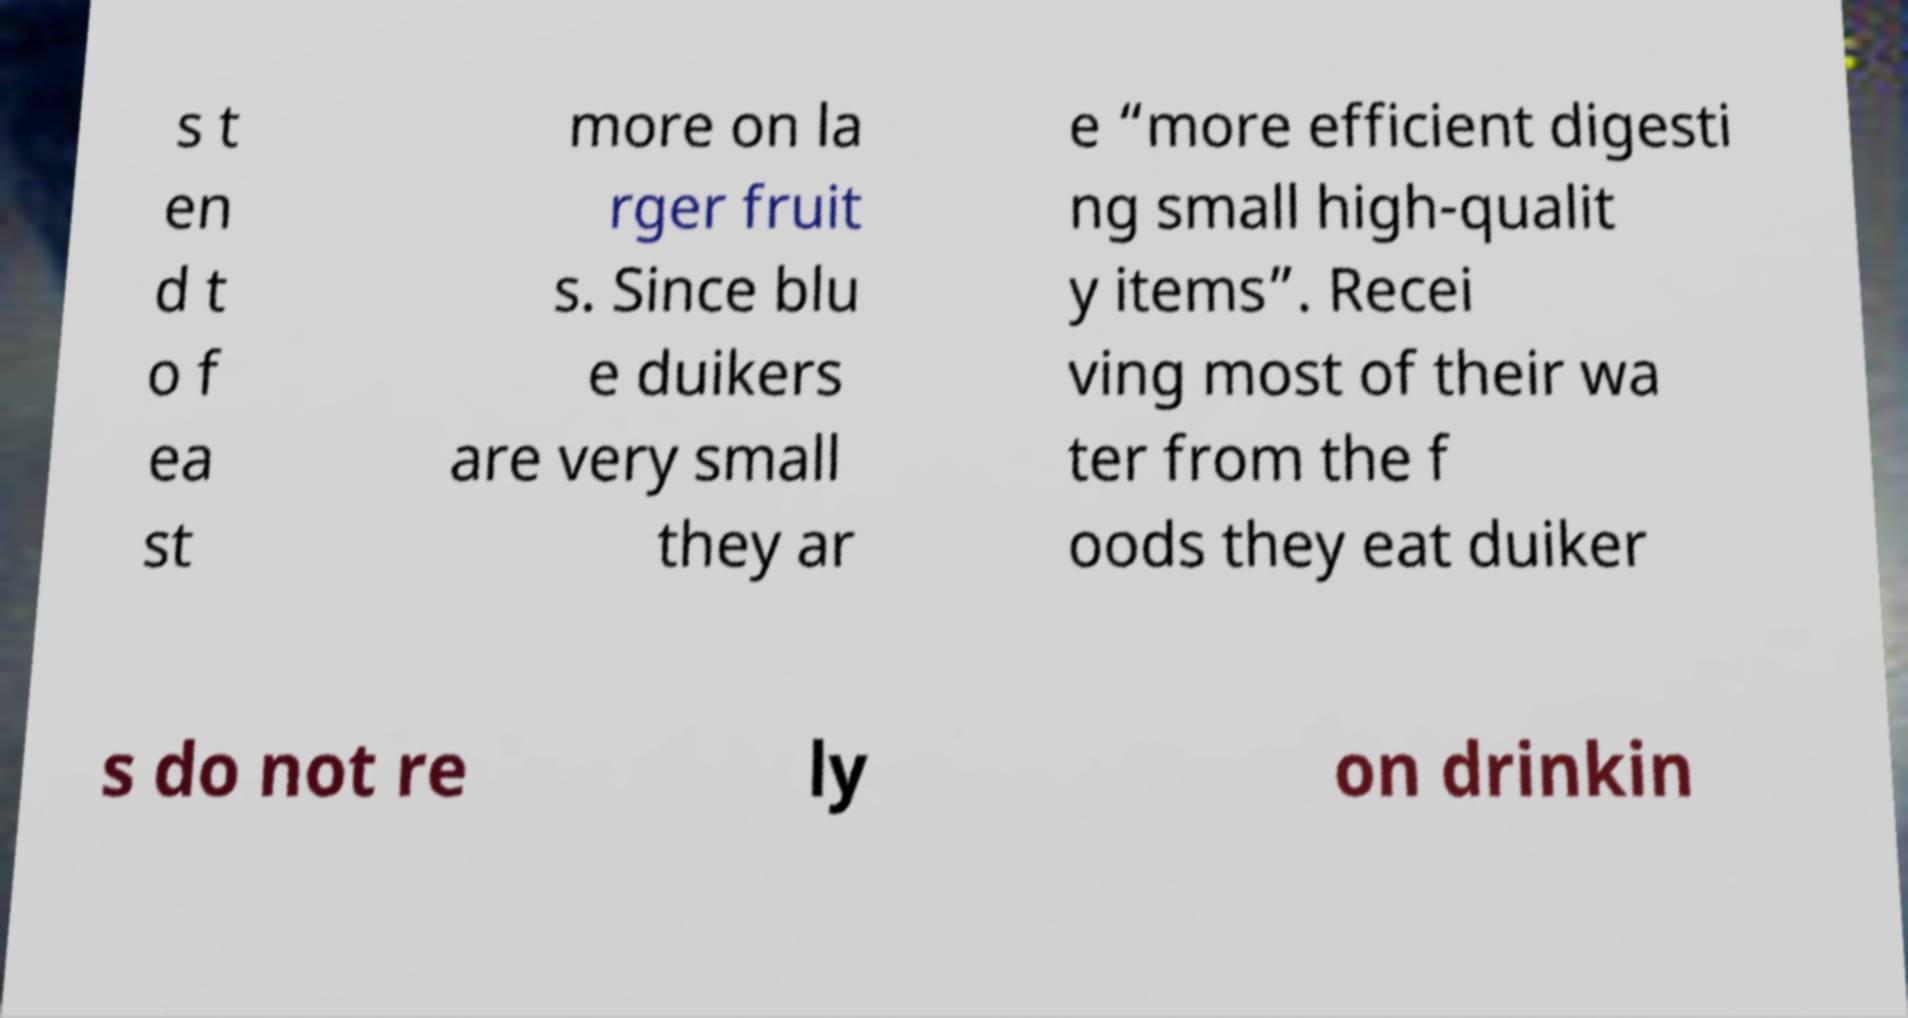Can you accurately transcribe the text from the provided image for me? s t en d t o f ea st more on la rger fruit s. Since blu e duikers are very small they ar e “more efficient digesti ng small high-qualit y items”. Recei ving most of their wa ter from the f oods they eat duiker s do not re ly on drinkin 